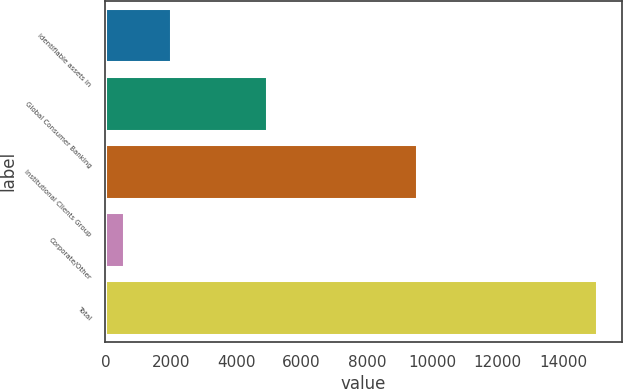Convert chart to OTSL. <chart><loc_0><loc_0><loc_500><loc_500><bar_chart><fcel>identifiable assets in<fcel>Global Consumer Banking<fcel>Institutional Clients Group<fcel>Corporate/Other<fcel>Total<nl><fcel>2022.6<fcel>4931<fcel>9525<fcel>577<fcel>15033<nl></chart> 